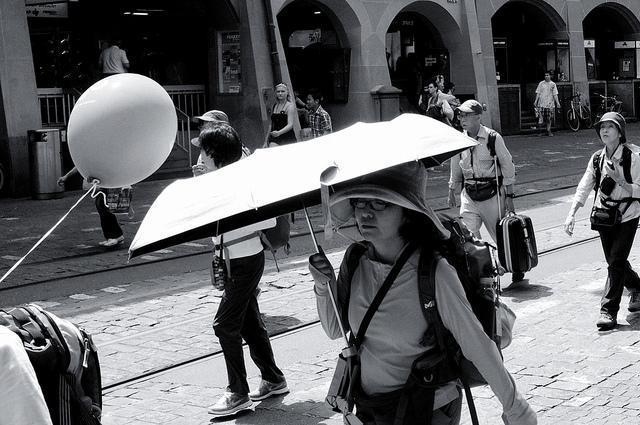How many backpacks are in the photo?
Give a very brief answer. 2. How many people are in the photo?
Give a very brief answer. 5. 